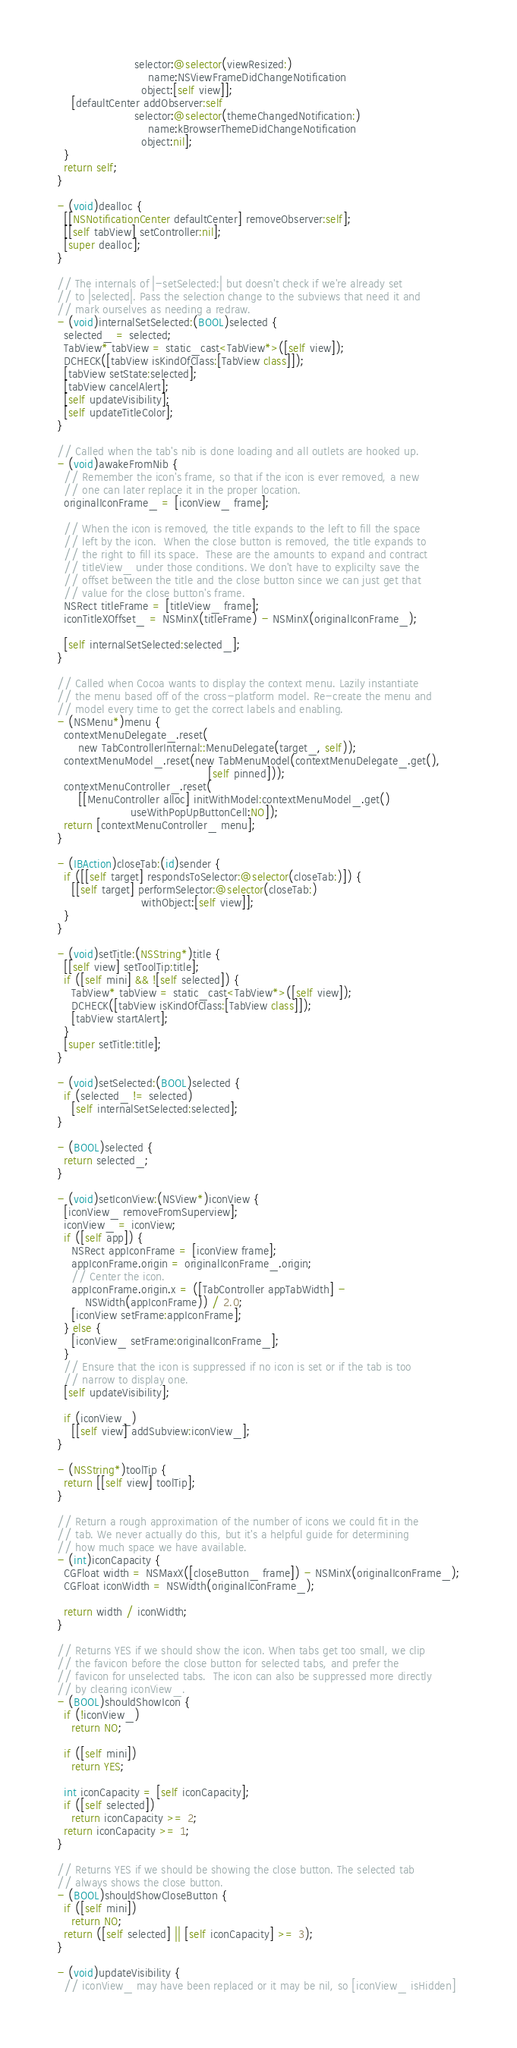Convert code to text. <code><loc_0><loc_0><loc_500><loc_500><_ObjectiveC_>                      selector:@selector(viewResized:)
                          name:NSViewFrameDidChangeNotification
                        object:[self view]];
    [defaultCenter addObserver:self
                      selector:@selector(themeChangedNotification:)
                          name:kBrowserThemeDidChangeNotification
                        object:nil];
  }
  return self;
}

- (void)dealloc {
  [[NSNotificationCenter defaultCenter] removeObserver:self];
  [[self tabView] setController:nil];
  [super dealloc];
}

// The internals of |-setSelected:| but doesn't check if we're already set
// to |selected|. Pass the selection change to the subviews that need it and
// mark ourselves as needing a redraw.
- (void)internalSetSelected:(BOOL)selected {
  selected_ = selected;
  TabView* tabView = static_cast<TabView*>([self view]);
  DCHECK([tabView isKindOfClass:[TabView class]]);
  [tabView setState:selected];
  [tabView cancelAlert];
  [self updateVisibility];
  [self updateTitleColor];
}

// Called when the tab's nib is done loading and all outlets are hooked up.
- (void)awakeFromNib {
  // Remember the icon's frame, so that if the icon is ever removed, a new
  // one can later replace it in the proper location.
  originalIconFrame_ = [iconView_ frame];

  // When the icon is removed, the title expands to the left to fill the space
  // left by the icon.  When the close button is removed, the title expands to
  // the right to fill its space.  These are the amounts to expand and contract
  // titleView_ under those conditions. We don't have to explicilty save the
  // offset between the title and the close button since we can just get that
  // value for the close button's frame.
  NSRect titleFrame = [titleView_ frame];
  iconTitleXOffset_ = NSMinX(titleFrame) - NSMinX(originalIconFrame_);

  [self internalSetSelected:selected_];
}

// Called when Cocoa wants to display the context menu. Lazily instantiate
// the menu based off of the cross-platform model. Re-create the menu and
// model every time to get the correct labels and enabling.
- (NSMenu*)menu {
  contextMenuDelegate_.reset(
      new TabControllerInternal::MenuDelegate(target_, self));
  contextMenuModel_.reset(new TabMenuModel(contextMenuDelegate_.get(),
                                           [self pinned]));
  contextMenuController_.reset(
      [[MenuController alloc] initWithModel:contextMenuModel_.get()
                     useWithPopUpButtonCell:NO]);
  return [contextMenuController_ menu];
}

- (IBAction)closeTab:(id)sender {
  if ([[self target] respondsToSelector:@selector(closeTab:)]) {
    [[self target] performSelector:@selector(closeTab:)
                        withObject:[self view]];
  }
}

- (void)setTitle:(NSString*)title {
  [[self view] setToolTip:title];
  if ([self mini] && ![self selected]) {
    TabView* tabView = static_cast<TabView*>([self view]);
    DCHECK([tabView isKindOfClass:[TabView class]]);
    [tabView startAlert];
  }
  [super setTitle:title];
}

- (void)setSelected:(BOOL)selected {
  if (selected_ != selected)
    [self internalSetSelected:selected];
}

- (BOOL)selected {
  return selected_;
}

- (void)setIconView:(NSView*)iconView {
  [iconView_ removeFromSuperview];
  iconView_ = iconView;
  if ([self app]) {
    NSRect appIconFrame = [iconView frame];
    appIconFrame.origin = originalIconFrame_.origin;
    // Center the icon.
    appIconFrame.origin.x = ([TabController appTabWidth] -
        NSWidth(appIconFrame)) / 2.0;
    [iconView setFrame:appIconFrame];
  } else {
    [iconView_ setFrame:originalIconFrame_];
  }
  // Ensure that the icon is suppressed if no icon is set or if the tab is too
  // narrow to display one.
  [self updateVisibility];

  if (iconView_)
    [[self view] addSubview:iconView_];
}

- (NSString*)toolTip {
  return [[self view] toolTip];
}

// Return a rough approximation of the number of icons we could fit in the
// tab. We never actually do this, but it's a helpful guide for determining
// how much space we have available.
- (int)iconCapacity {
  CGFloat width = NSMaxX([closeButton_ frame]) - NSMinX(originalIconFrame_);
  CGFloat iconWidth = NSWidth(originalIconFrame_);

  return width / iconWidth;
}

// Returns YES if we should show the icon. When tabs get too small, we clip
// the favicon before the close button for selected tabs, and prefer the
// favicon for unselected tabs.  The icon can also be suppressed more directly
// by clearing iconView_.
- (BOOL)shouldShowIcon {
  if (!iconView_)
    return NO;

  if ([self mini])
    return YES;

  int iconCapacity = [self iconCapacity];
  if ([self selected])
    return iconCapacity >= 2;
  return iconCapacity >= 1;
}

// Returns YES if we should be showing the close button. The selected tab
// always shows the close button.
- (BOOL)shouldShowCloseButton {
  if ([self mini])
    return NO;
  return ([self selected] || [self iconCapacity] >= 3);
}

- (void)updateVisibility {
  // iconView_ may have been replaced or it may be nil, so [iconView_ isHidden]</code> 